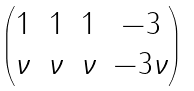<formula> <loc_0><loc_0><loc_500><loc_500>\begin{pmatrix} 1 & 1 & 1 & - 3 \\ \nu & \nu & \nu & - 3 \nu \end{pmatrix}</formula> 